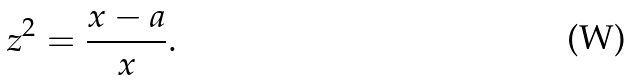Convert formula to latex. <formula><loc_0><loc_0><loc_500><loc_500>z ^ { 2 } = \frac { x - a } { x } .</formula> 